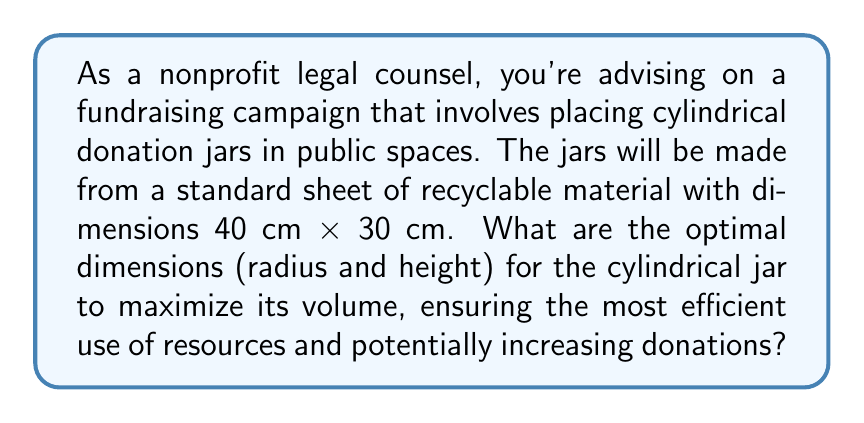Can you solve this math problem? To solve this problem, we need to follow these steps:

1) The volume of a cylinder is given by the formula:
   $$V = \pi r^2 h$$
   where $r$ is the radius and $h$ is the height.

2) The cylindrical jar will be made from a rectangular sheet. The circumference of the base plus the height of the cylinder must equal the length of the sheet:
   $$2\pi r + h = 40$$

3) The height of the cylinder must equal the width of the sheet:
   $$h = 30$$

4) Substituting these into the volume formula:
   $$V = \pi r^2 (40 - 2\pi r)$$

5) To find the maximum volume, we differentiate $V$ with respect to $r$ and set it to zero:
   $$\frac{dV}{dr} = 2\pi r(40 - 2\pi r) - 2\pi^2 r^2 = 0$$

6) Simplifying:
   $$80\pi r - 6\pi^2 r^2 = 0$$
   $$r(80\pi - 6\pi^2 r) = 0$$

7) Solving this equation:
   $$r = 0$$ (which we can discard as it gives zero volume)
   or
   $$80\pi - 6\pi^2 r = 0$$
   $$r = \frac{80\pi}{6\pi^2} = \frac{40}{3\pi} \approx 4.24 \text{ cm}$$

8) The optimal height will be:
   $$h = 40 - 2\pi r = 40 - 2\pi(\frac{40}{3\pi}) = \frac{40}{3} \approx 13.33 \text{ cm}$$

9) We can verify this is a maximum by checking the second derivative is negative at this point.

[asy]
size(200,200);
import graph;

real r = 40/(3*pi);
real h = 40/3;

draw(circle((0,0),r));
draw((r,0)--(r,h)--(-r,h)--(-r,0));
draw((-r,0)..(0,-r)..(r,0),dashed);

label("r",(r/2,-r/2),SE);
label("h",(r,h/2),E);

[/asy]
Answer: The optimal dimensions for the cylindrical donation jar are:
Radius ≈ 4.24 cm
Height ≈ 13.33 cm 